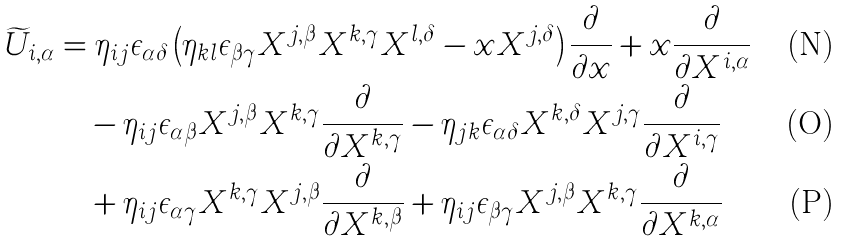<formula> <loc_0><loc_0><loc_500><loc_500>\widetilde { U } _ { i , \alpha } & = \eta _ { i j } \epsilon _ { \alpha \delta } \left ( \eta _ { k l } \epsilon _ { \beta \gamma } X ^ { j , \beta } X ^ { k , \gamma } X ^ { l , \delta } - x X ^ { j , \delta } \right ) \frac { \partial } { \partial x } + x \frac { \partial } { \partial X ^ { i , \alpha } } \\ & \quad - \eta _ { i j } \epsilon _ { \alpha \beta } X ^ { j , \beta } X ^ { k , \gamma } \frac { \partial } { \partial X ^ { k , \gamma } } - \eta _ { j k } \epsilon _ { \alpha \delta } X ^ { k , \delta } X ^ { j , \gamma } \frac { \partial } { \partial X ^ { i , \gamma } } \\ & \quad + \eta _ { i j } \epsilon _ { \alpha \gamma } X ^ { k , \gamma } X ^ { j , \beta } \frac { \partial } { \partial X ^ { k , \beta } } + \eta _ { i j } \epsilon _ { \beta \gamma } X ^ { j , \beta } X ^ { k , \gamma } \frac { \partial } { \partial X ^ { k , \alpha } }</formula> 